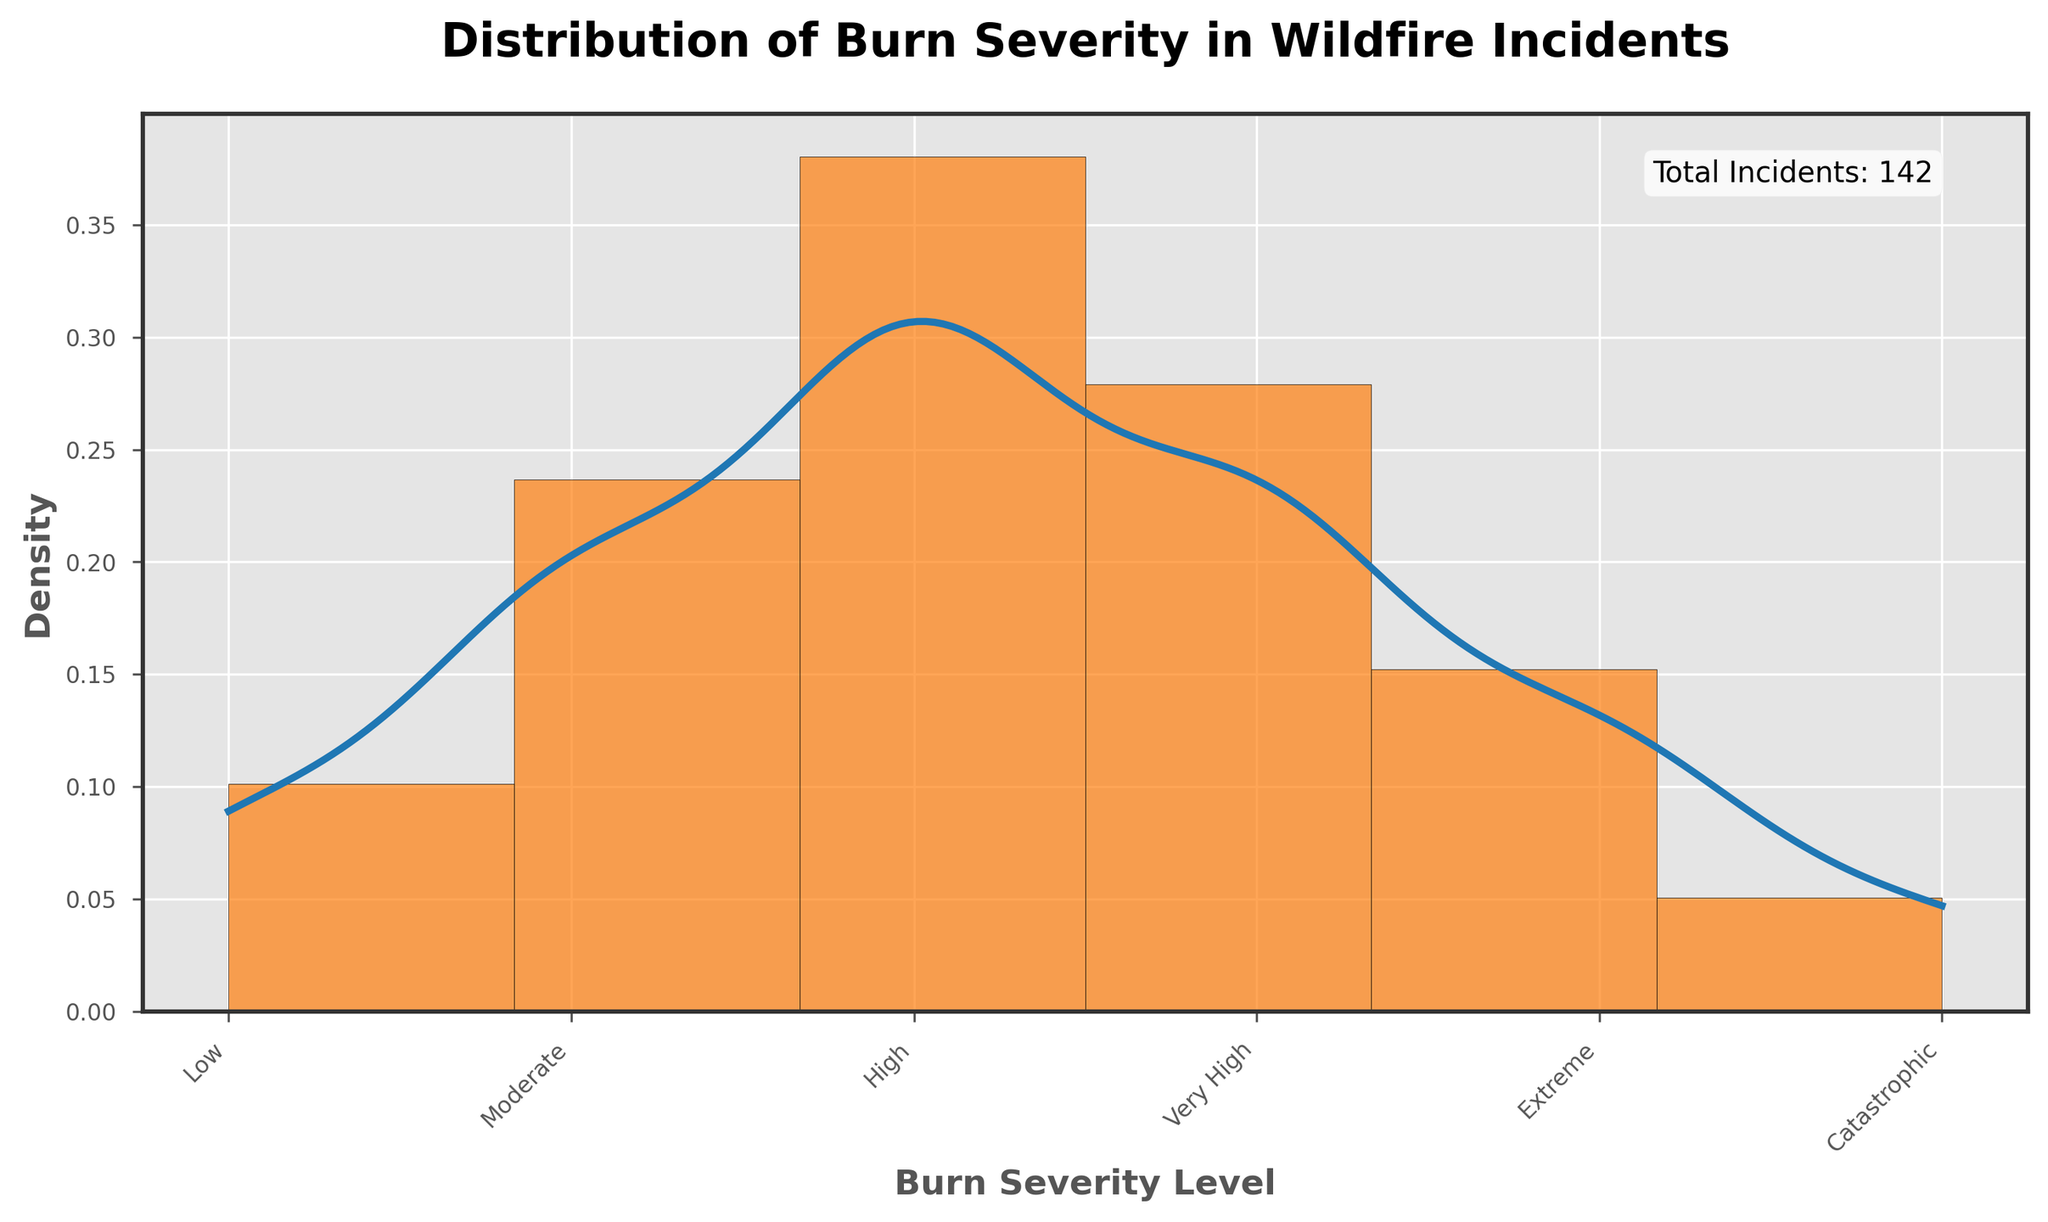What is the title of the figure? The title of the figure is located at the top and is usually in bold text, providing a succinct summary of the data being displayed.
Answer: Distribution of Burn Severity in Wildfire Incidents How many severity levels are shown in the histogram? Count the individual labels on the x-axis, which correspond to the categories of burn severity levels.
Answer: Six Which burn severity level has the highest number of incidents? Look for the tallest bar in the histogram and identify the corresponding burn severity level on the x-axis.
Answer: High What is the total number of wildfire incidents shown in the figure? Look at the text annotation within the figure that provides the total count of incidents.
Answer: 142 What is the shape of the KDE curve and how does it relate to the histogram bars? Observe the blue density curve (KDE) and describe its shape, noting how it generally follows the distribution of the histogram bars.
Answer: The KDE curve forms peaks over the areas with higher bar heights, indicating higher density where incidences are more frequent How does the number of 'Very High' severity incidents compare to 'Extreme' severity incidents? Compare the heights of the bars corresponding to 'Very High' and 'Extreme' severity levels to see which one is taller.
Answer: The 'Very High' severity level has more incidents than the 'Extreme' severity level What does the x-axis represent in this figure? Read the label on the x-axis to understand what it is depicting in terms of the data shown.
Answer: Burn Severity Level What percentage of the total incidents are 'Moderate' severity? Determine the number of 'Moderate' severity incidents, then divide by the total number of incidents and multiply by 100 to get the percentage.
Answer: (28/142) * 100 ≈ 19.72% Which burn severity levels have fewer than 20 incidents? Identify the bars on the histogram with heights (incident counts) less than 20 and note their respective severity levels.
Answer: Low, Extreme, Catastrophic What is the approximate density value at the 'High' severity level on the KDE curve? Trace vertically from the 'High' severity level on the x-axis to the density curve, then horizontally to the y-axis to find the density value.
Answer: Approximately 0.12 